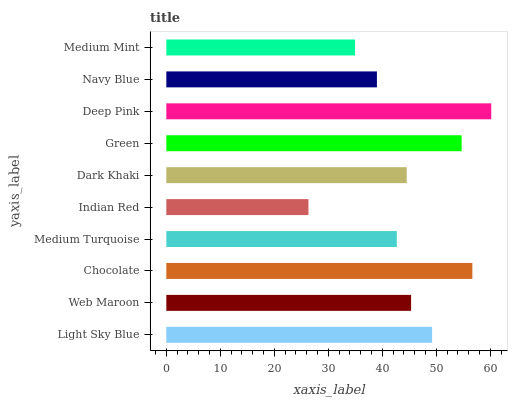Is Indian Red the minimum?
Answer yes or no. Yes. Is Deep Pink the maximum?
Answer yes or no. Yes. Is Web Maroon the minimum?
Answer yes or no. No. Is Web Maroon the maximum?
Answer yes or no. No. Is Light Sky Blue greater than Web Maroon?
Answer yes or no. Yes. Is Web Maroon less than Light Sky Blue?
Answer yes or no. Yes. Is Web Maroon greater than Light Sky Blue?
Answer yes or no. No. Is Light Sky Blue less than Web Maroon?
Answer yes or no. No. Is Web Maroon the high median?
Answer yes or no. Yes. Is Dark Khaki the low median?
Answer yes or no. Yes. Is Light Sky Blue the high median?
Answer yes or no. No. Is Indian Red the low median?
Answer yes or no. No. 